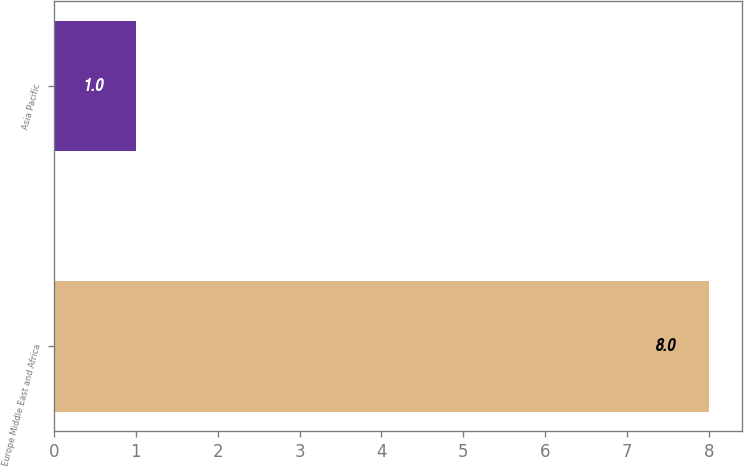Convert chart. <chart><loc_0><loc_0><loc_500><loc_500><bar_chart><fcel>Europe Middle East and Africa<fcel>Asia Pacific<nl><fcel>8<fcel>1<nl></chart> 